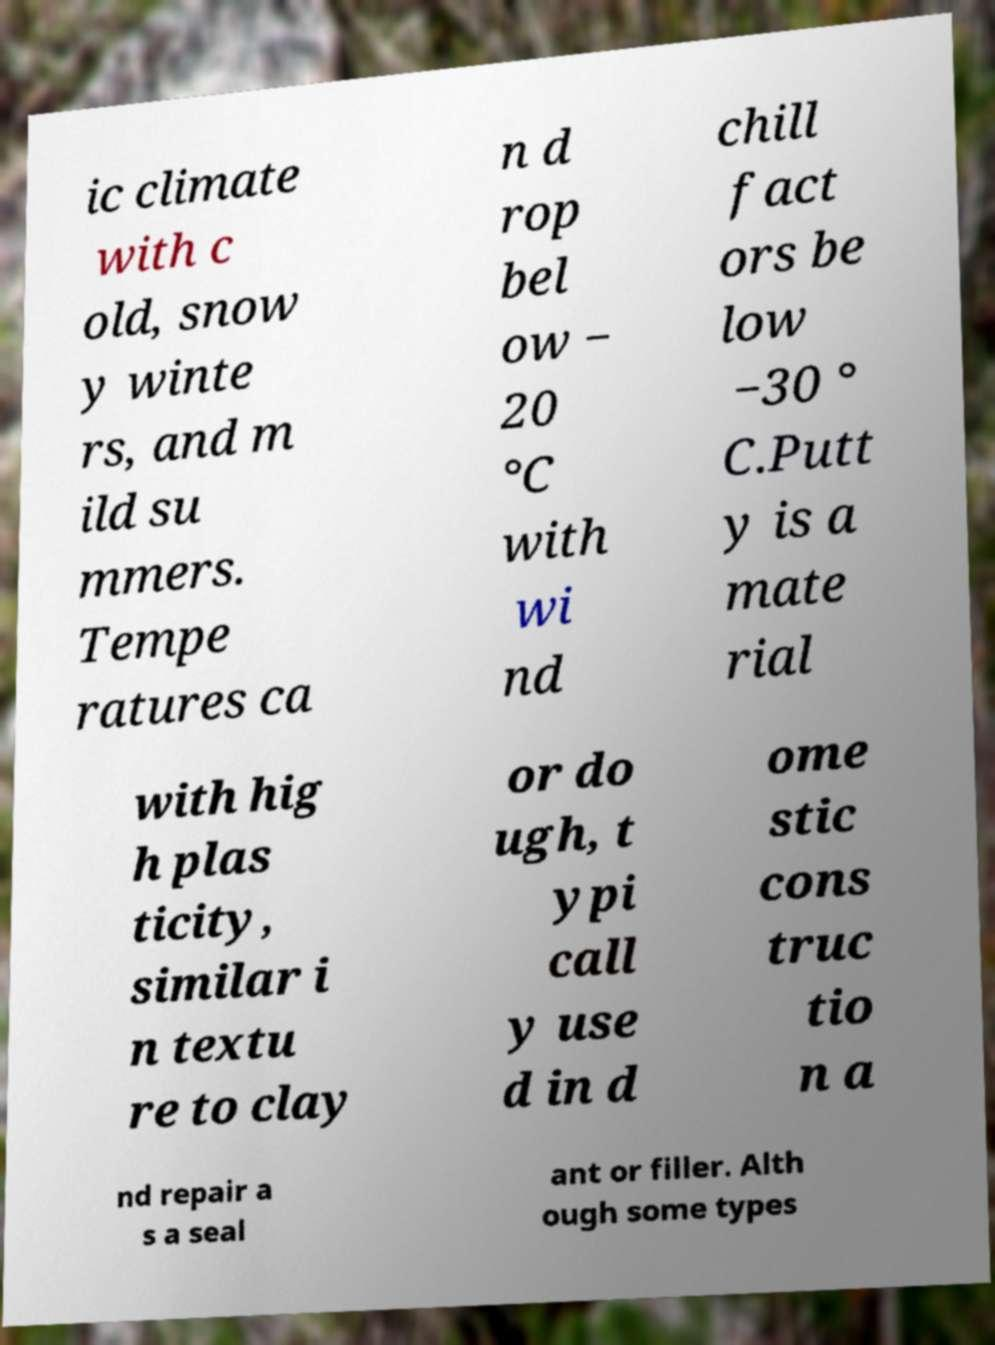Could you assist in decoding the text presented in this image and type it out clearly? ic climate with c old, snow y winte rs, and m ild su mmers. Tempe ratures ca n d rop bel ow − 20 °C with wi nd chill fact ors be low −30 ° C.Putt y is a mate rial with hig h plas ticity, similar i n textu re to clay or do ugh, t ypi call y use d in d ome stic cons truc tio n a nd repair a s a seal ant or filler. Alth ough some types 